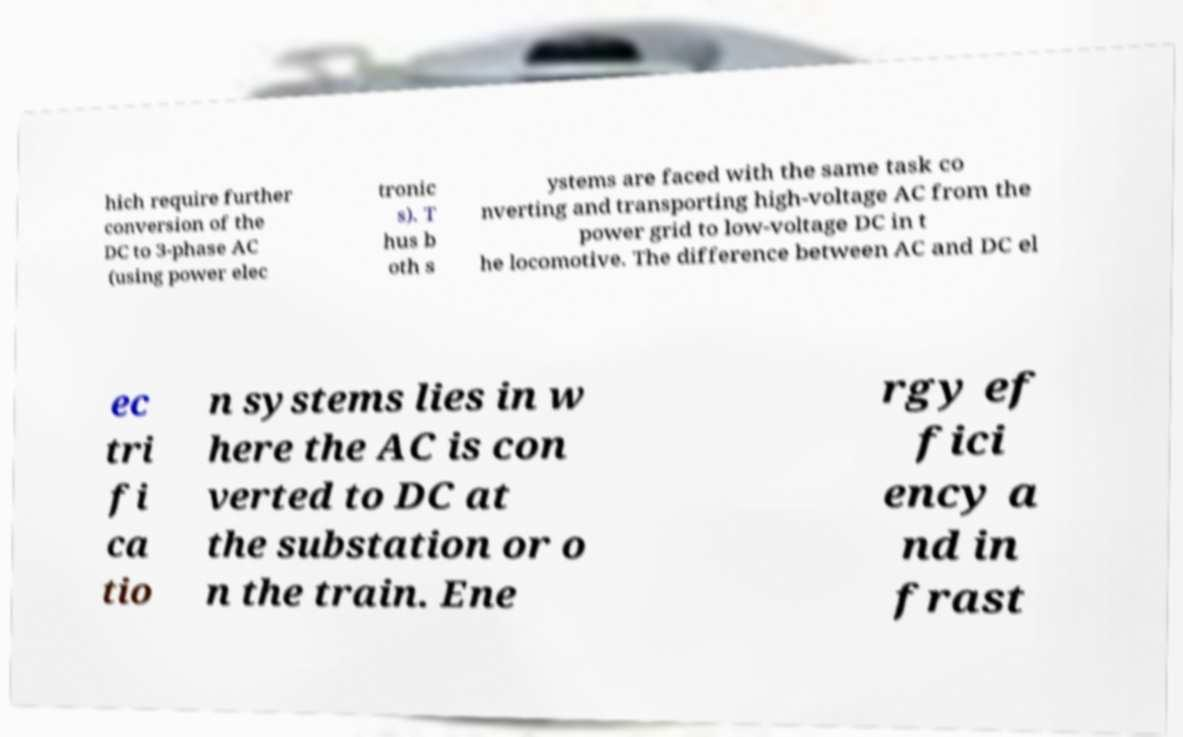Could you assist in decoding the text presented in this image and type it out clearly? hich require further conversion of the DC to 3-phase AC (using power elec tronic s). T hus b oth s ystems are faced with the same task co nverting and transporting high-voltage AC from the power grid to low-voltage DC in t he locomotive. The difference between AC and DC el ec tri fi ca tio n systems lies in w here the AC is con verted to DC at the substation or o n the train. Ene rgy ef fici ency a nd in frast 